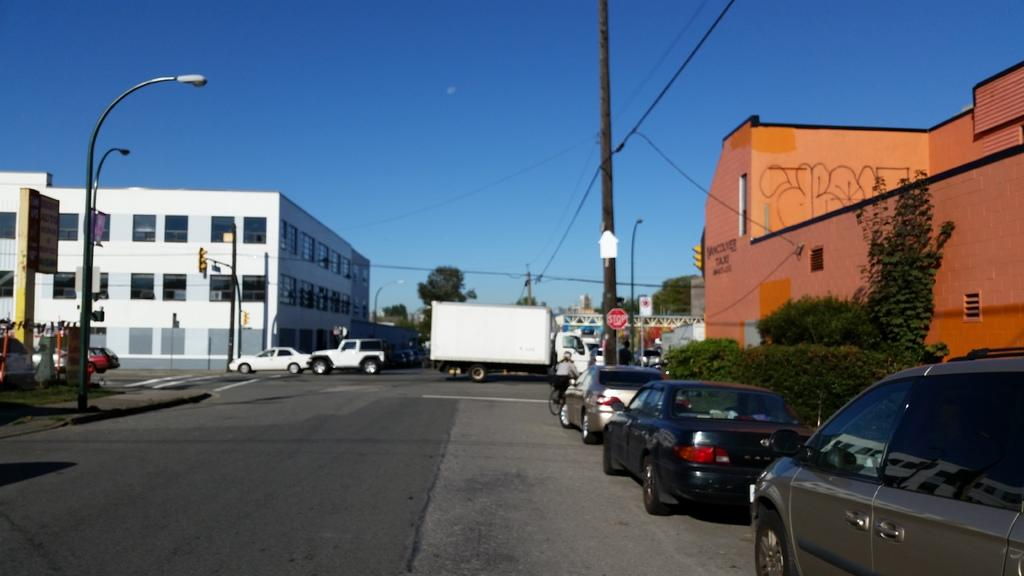What type of structures can be seen in the image? There are buildings in the image. What type of vegetation is present in the image? There are trees and shrubs in the image. What type of street furniture can be seen in the image? There are light poles in the image. What type of transportation is visible in the image? There are vehicles in the image. What type of signage is present in the image? There are boards in the image. What type of utility infrastructure is present in the image? There are wires in the image. What type of surface can be seen in the image? There is a road in the image. What part of the natural environment is visible in the image? The sky is visible in the image. How many snails can be seen crawling on the boards in the image? There are no snails present in the image. What type of religious symbolism can be seen on the buildings in the image? There is no religious symbolism present on the buildings in the image. 